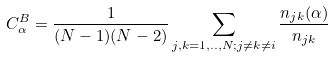Convert formula to latex. <formula><loc_0><loc_0><loc_500><loc_500>C ^ { B } _ { \alpha } = \frac { 1 } { ( N - 1 ) ( N - 2 ) } \sum _ { j , k = 1 , . . , N ; j \neq k \neq i } \frac { n _ { j k } ( \alpha ) } { n _ { j k } }</formula> 